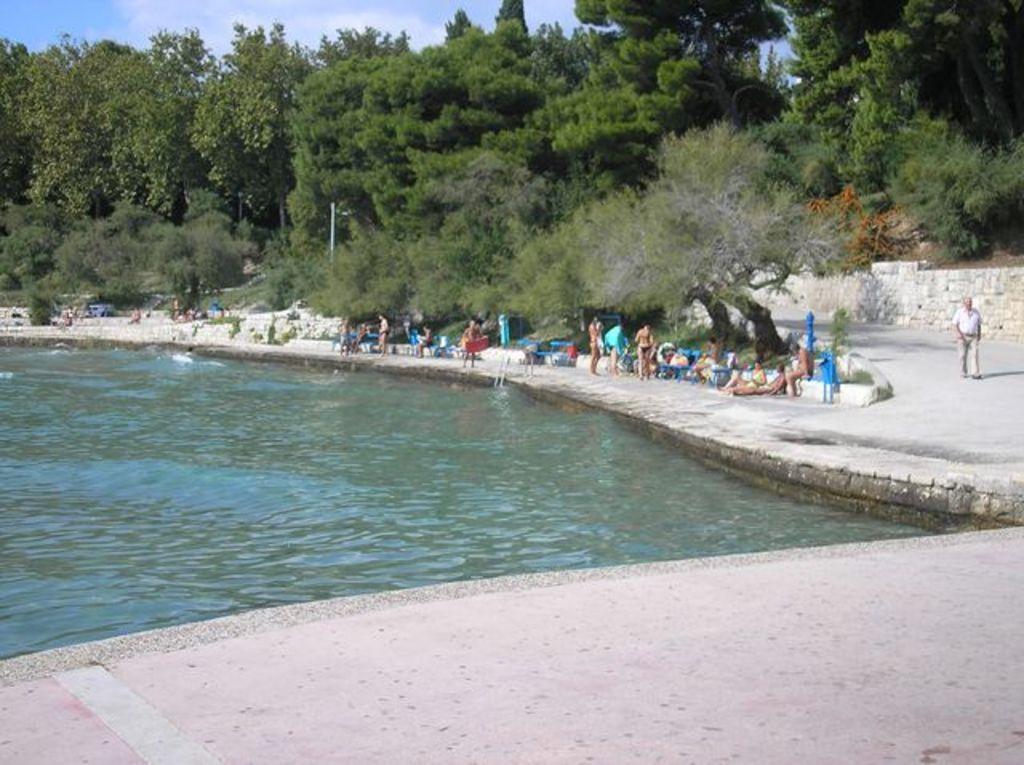Can you describe this image briefly? In the foreground of this image, there is a pool and a side path on the bottom side of the image. In the background, there are persons, a man walking on the road, trees, sky and the cloud. 